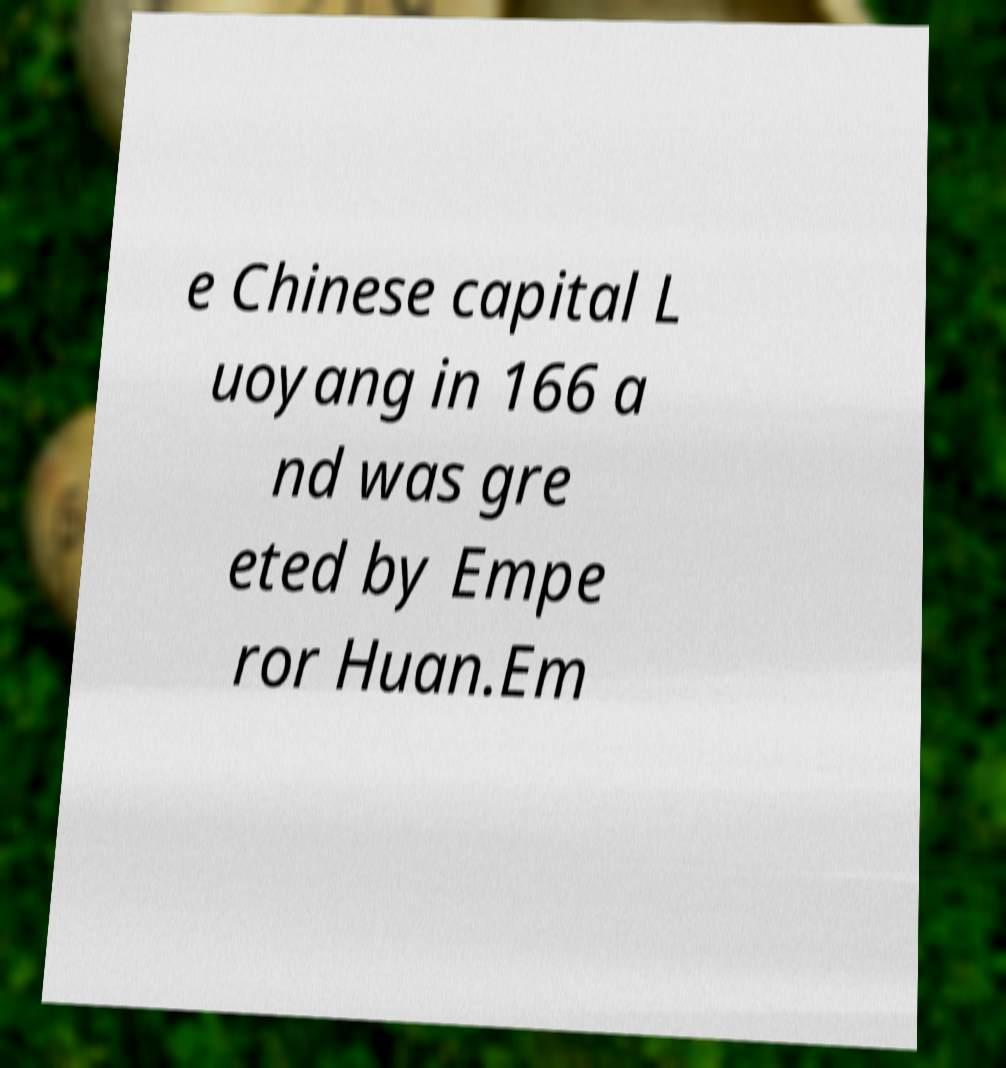Could you extract and type out the text from this image? e Chinese capital L uoyang in 166 a nd was gre eted by Empe ror Huan.Em 